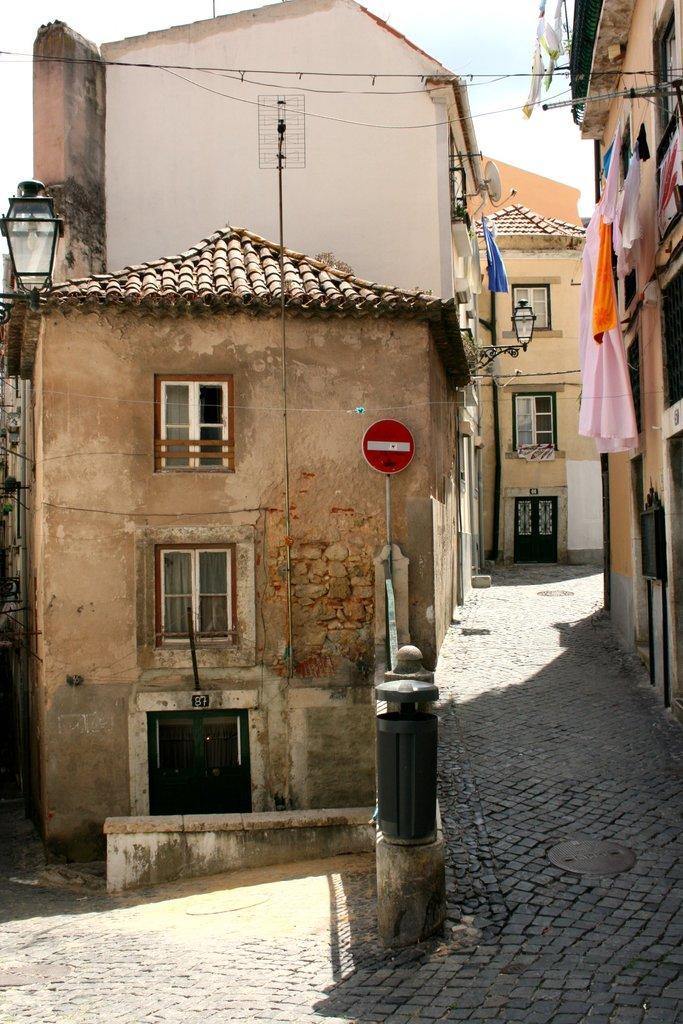Please provide a concise description of this image. In this image I can see few buildings, few lights, few clothes and number of windows. I can also see a red color sign board over here. 